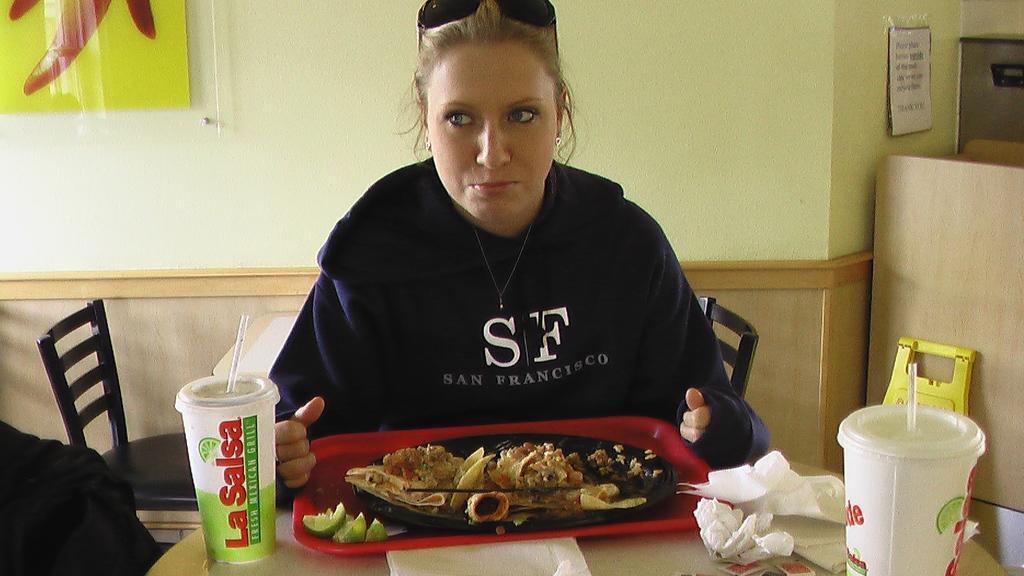In one or two sentences, can you explain what this image depicts? In the center of the image there is a lady sitting on the chair. In front of her there is a table on which there are many objects. There is a plate with food items in it. In the background of the image there is a wall. There are chairs and table. 